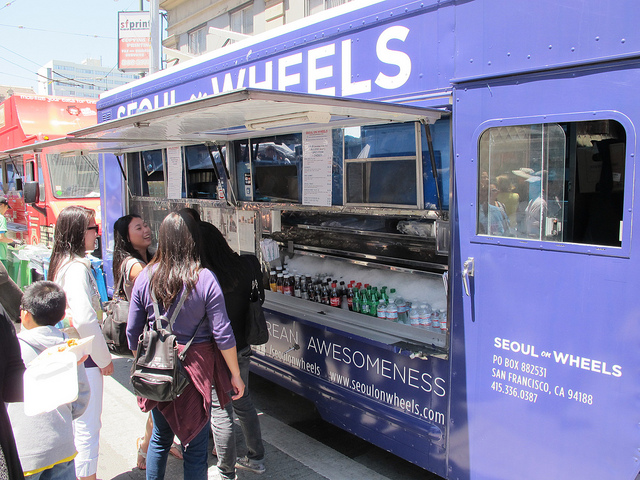Identify the text contained in this image. SEOUL on WHEELS CA 94188 REAN www.seulonwheels.com AWESOMENESS 882531 BOX FRANCISCO 415.336.0387 SAN po WHEELA siprint 